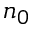<formula> <loc_0><loc_0><loc_500><loc_500>n _ { 0 }</formula> 